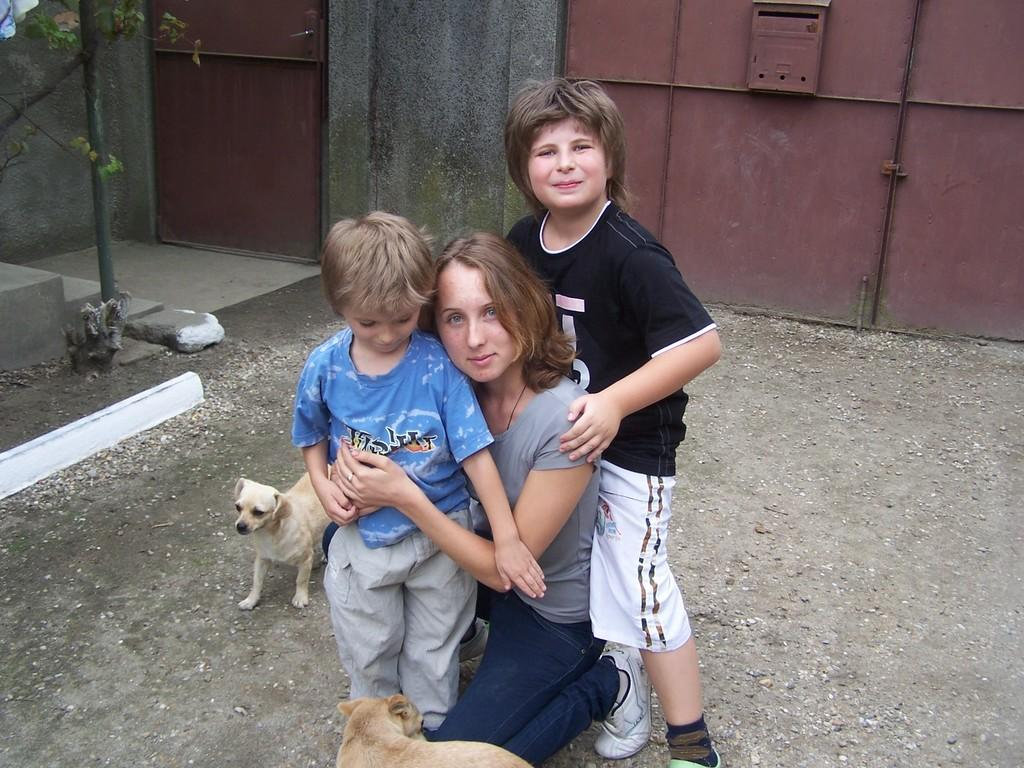How many people are in the image? There are three persons in the image. What are the persons doing in the image? The persons are posing for the camera. What other living creatures are present in the image? There are two puppies in the image. What can be seen in the background of the image? There are gates in the background of the image. What is the color of the gates? The gates are brown in color. What type of plant is visible in the image? There is a plant in the image. Can you hear the snakes laughing in the image? There are no snakes or sounds present in the image, so it is not possible to hear any laughter. 